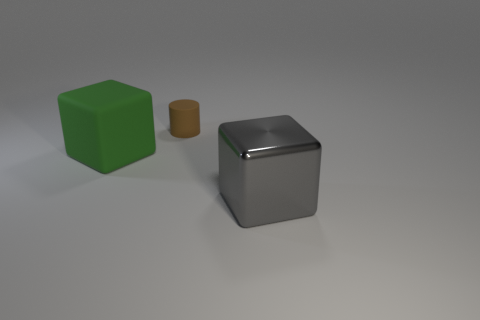Subtract all green cubes. How many cubes are left? 1 Add 3 tiny cyan cubes. How many objects exist? 6 Subtract all yellow matte cubes. Subtract all large cubes. How many objects are left? 1 Add 2 brown cylinders. How many brown cylinders are left? 3 Add 1 large rubber objects. How many large rubber objects exist? 2 Subtract 0 yellow blocks. How many objects are left? 3 Subtract all blocks. How many objects are left? 1 